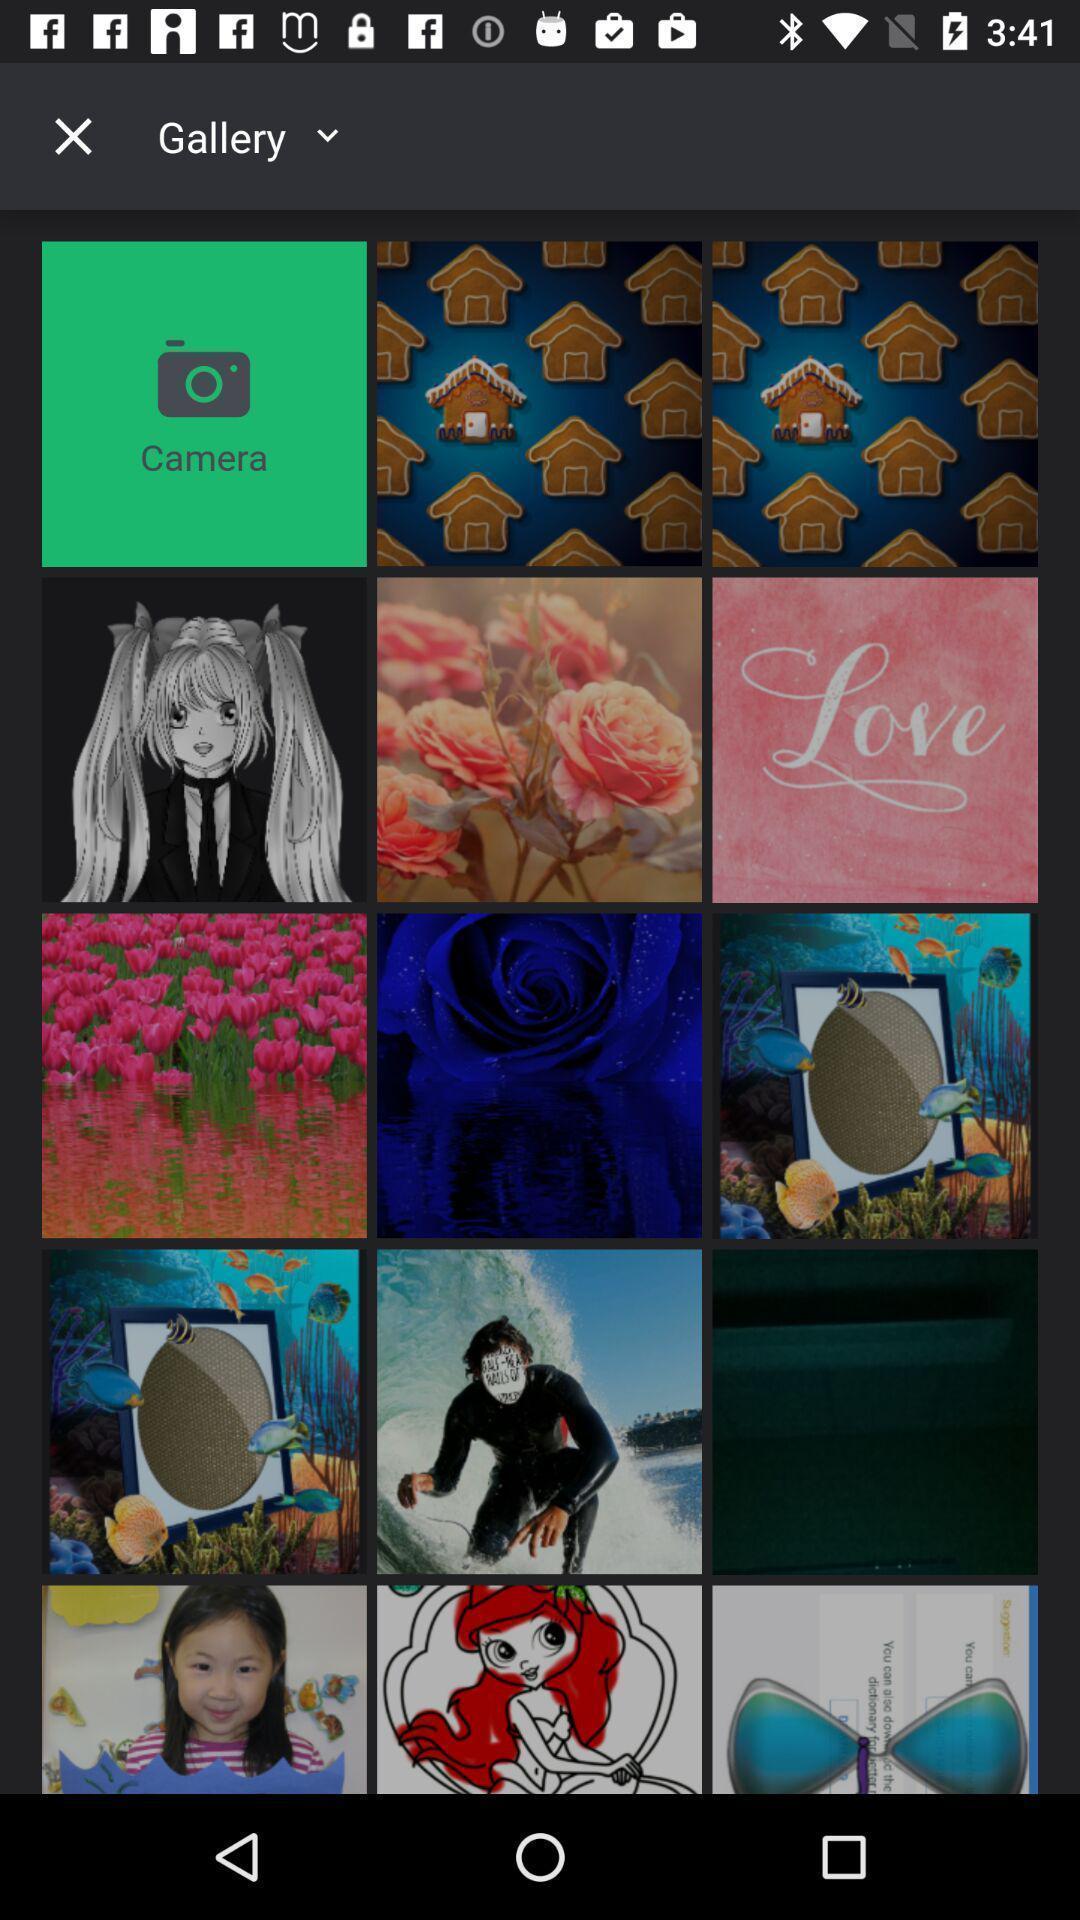Provide a description of this screenshot. Page displaying with multiple images. 